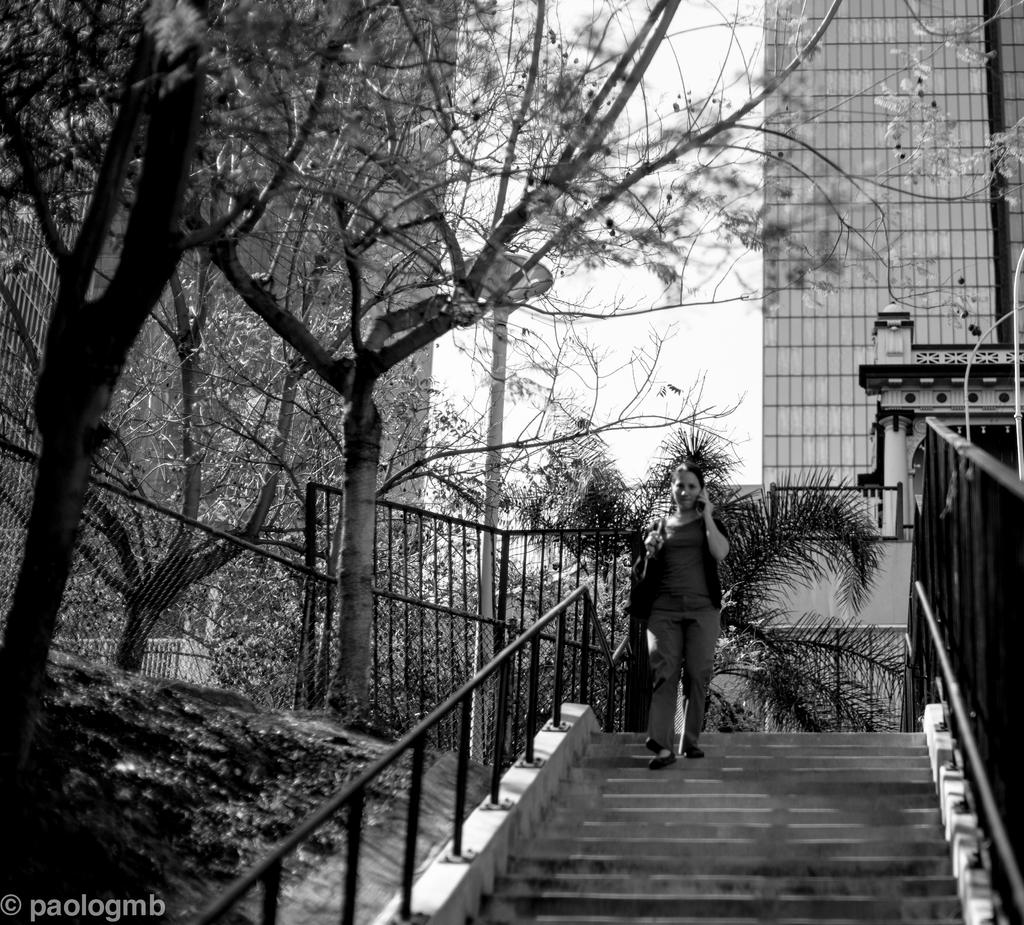What is the person in the image doing? A: The person is standing on the stairs. What can be seen in the background of the image? Trees and buildings are visible in the background. What is the color scheme of the image? The image is in black and white color. What type of twig can be seen in the person's hand in the image? There is no twig visible in the person's hand in the image. 